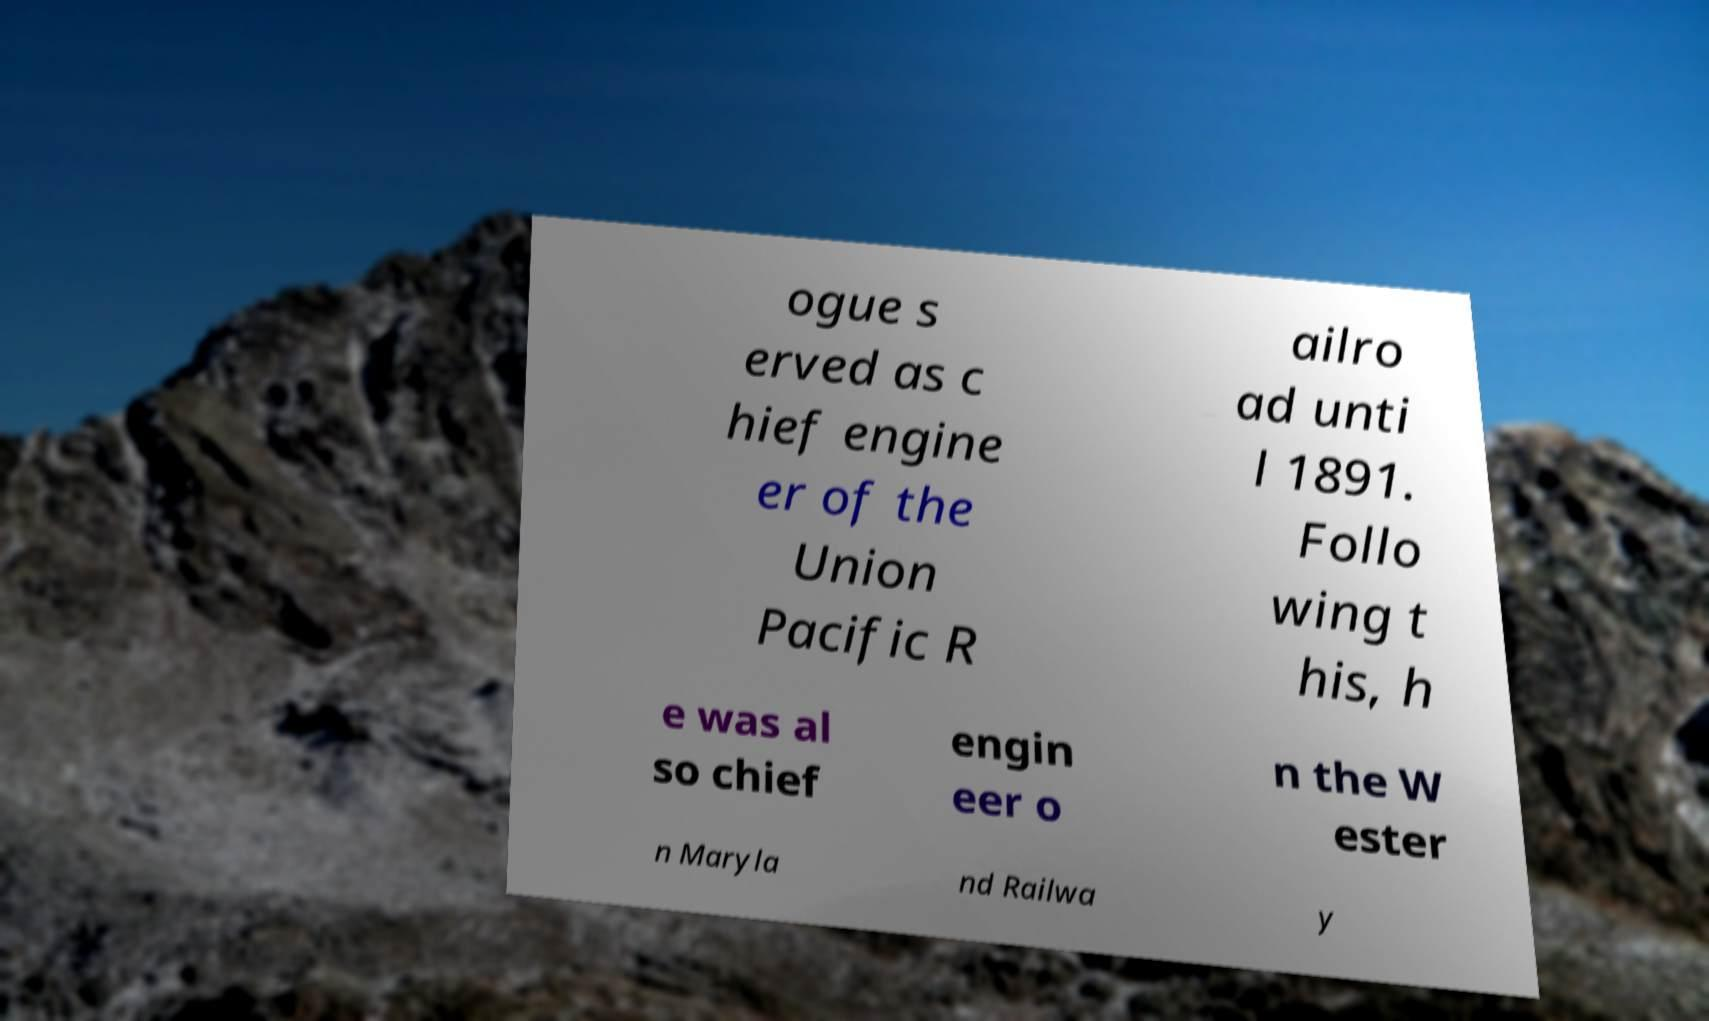Please read and relay the text visible in this image. What does it say? ogue s erved as c hief engine er of the Union Pacific R ailro ad unti l 1891. Follo wing t his, h e was al so chief engin eer o n the W ester n Maryla nd Railwa y 